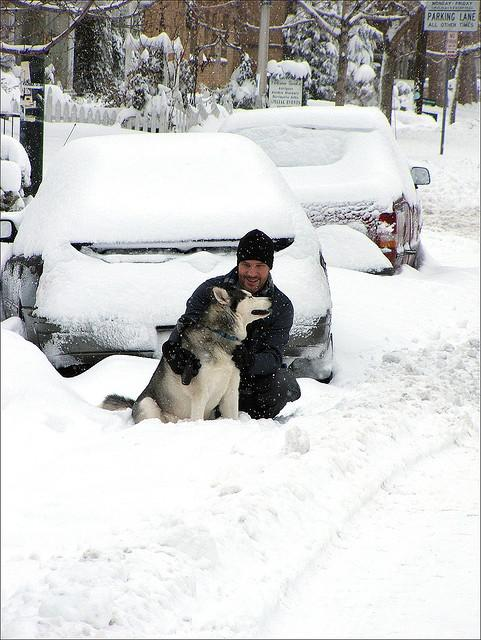This animal is the same species as what character on Game of Thrones? wolf 